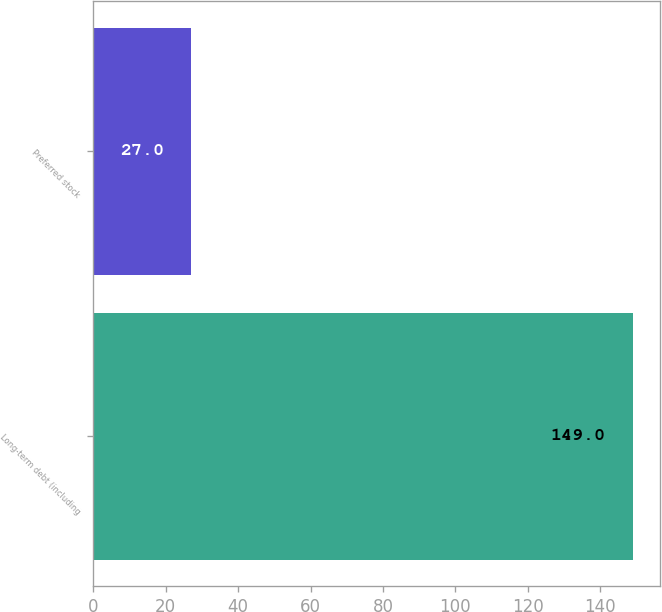Convert chart to OTSL. <chart><loc_0><loc_0><loc_500><loc_500><bar_chart><fcel>Long-term debt (including<fcel>Preferred stock<nl><fcel>149<fcel>27<nl></chart> 